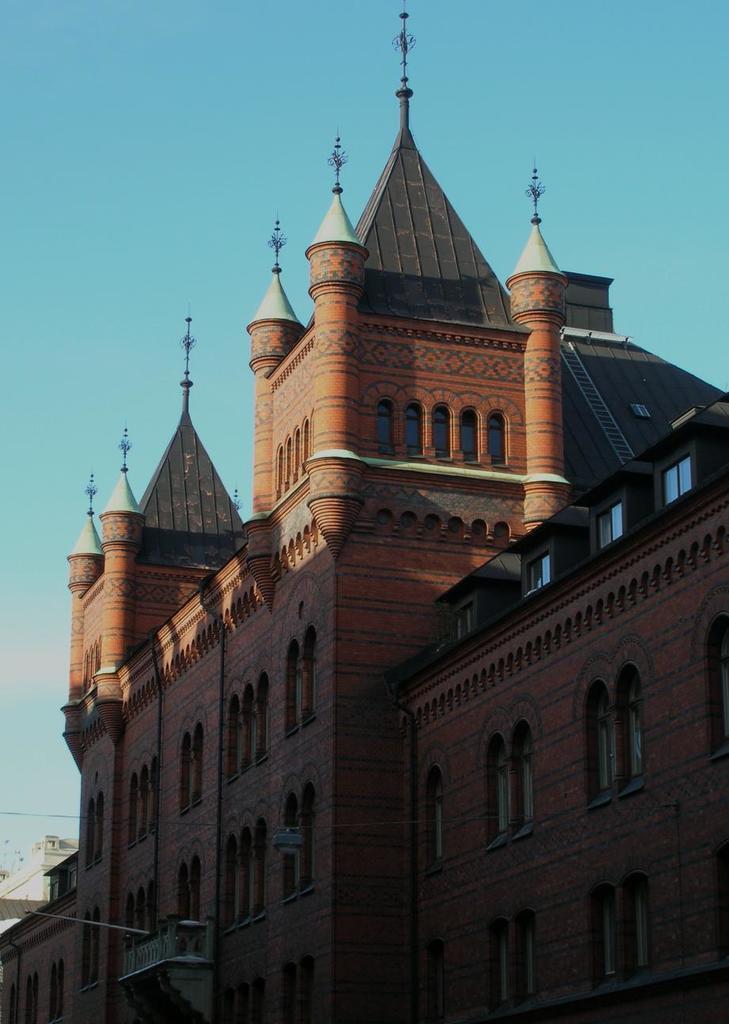In one or two sentences, can you explain what this image depicts? In this image we can see a building which looks like a palace and we can see the sky at the top. 